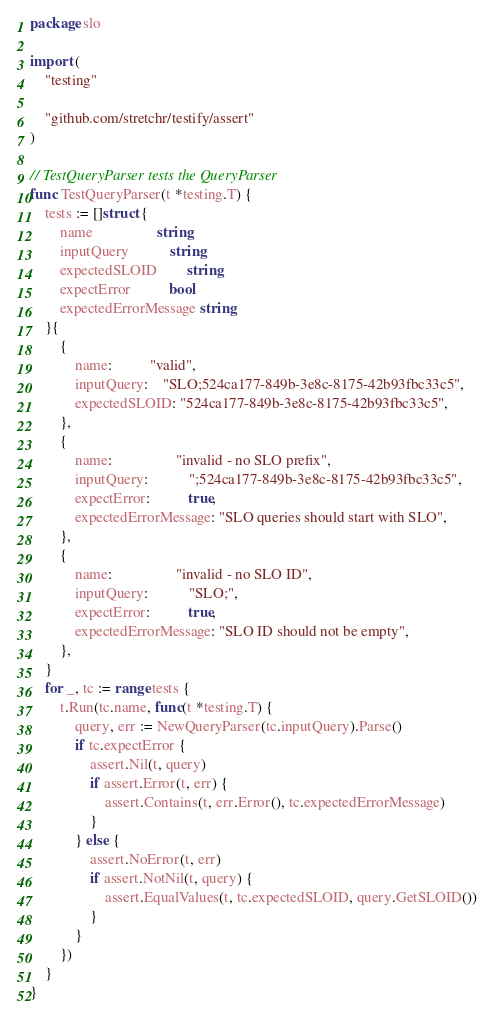Convert code to text. <code><loc_0><loc_0><loc_500><loc_500><_Go_>package slo

import (
	"testing"

	"github.com/stretchr/testify/assert"
)

// TestQueryParser tests the QueryParser
func TestQueryParser(t *testing.T) {
	tests := []struct {
		name                 string
		inputQuery           string
		expectedSLOID        string
		expectError          bool
		expectedErrorMessage string
	}{
		{
			name:          "valid",
			inputQuery:    "SLO;524ca177-849b-3e8c-8175-42b93fbc33c5",
			expectedSLOID: "524ca177-849b-3e8c-8175-42b93fbc33c5",
		},
		{
			name:                 "invalid - no SLO prefix",
			inputQuery:           ";524ca177-849b-3e8c-8175-42b93fbc33c5",
			expectError:          true,
			expectedErrorMessage: "SLO queries should start with SLO",
		},
		{
			name:                 "invalid - no SLO ID",
			inputQuery:           "SLO;",
			expectError:          true,
			expectedErrorMessage: "SLO ID should not be empty",
		},
	}
	for _, tc := range tests {
		t.Run(tc.name, func(t *testing.T) {
			query, err := NewQueryParser(tc.inputQuery).Parse()
			if tc.expectError {
				assert.Nil(t, query)
				if assert.Error(t, err) {
					assert.Contains(t, err.Error(), tc.expectedErrorMessage)
				}
			} else {
				assert.NoError(t, err)
				if assert.NotNil(t, query) {
					assert.EqualValues(t, tc.expectedSLOID, query.GetSLOID())
				}
			}
		})
	}
}
</code> 